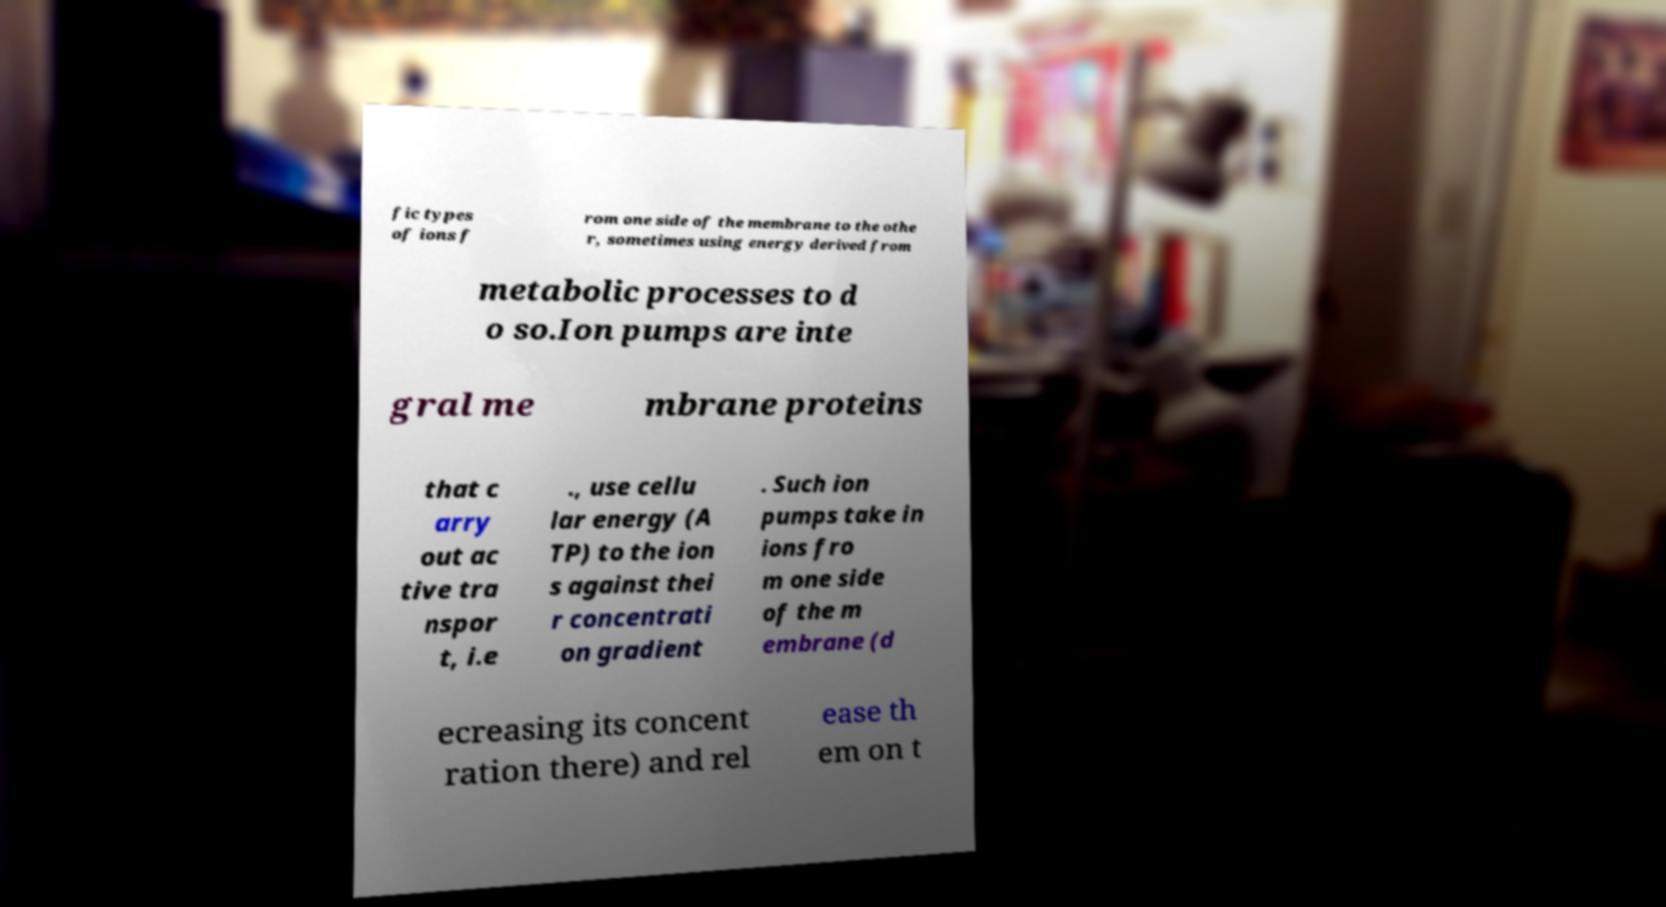Can you accurately transcribe the text from the provided image for me? fic types of ions f rom one side of the membrane to the othe r, sometimes using energy derived from metabolic processes to d o so.Ion pumps are inte gral me mbrane proteins that c arry out ac tive tra nspor t, i.e ., use cellu lar energy (A TP) to the ion s against thei r concentrati on gradient . Such ion pumps take in ions fro m one side of the m embrane (d ecreasing its concent ration there) and rel ease th em on t 